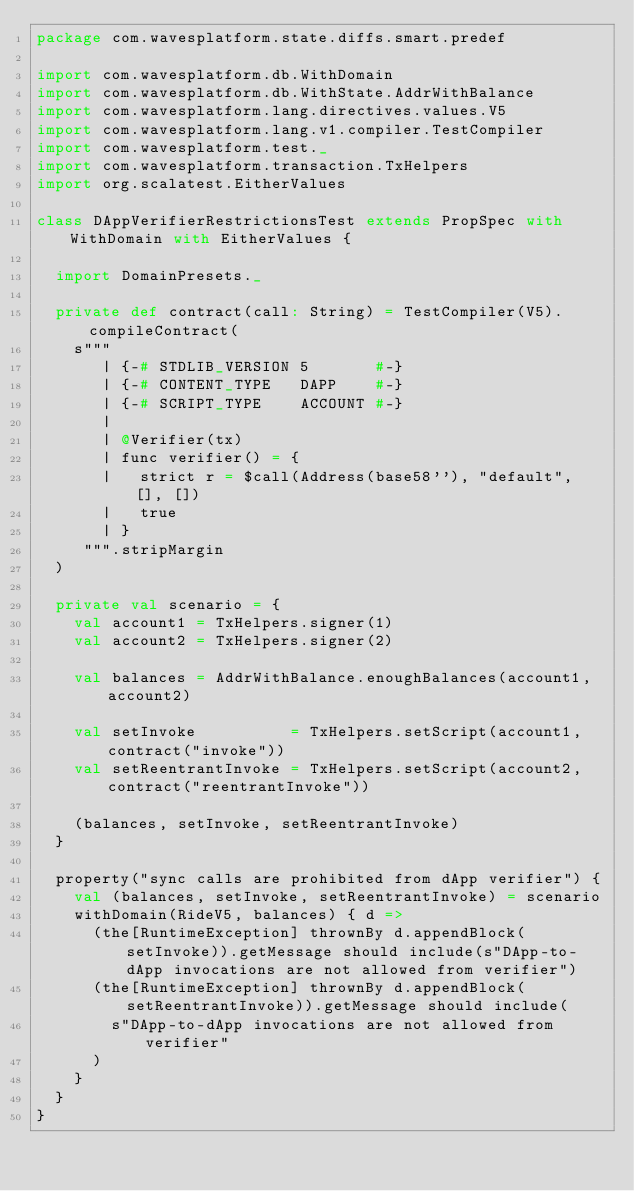Convert code to text. <code><loc_0><loc_0><loc_500><loc_500><_Scala_>package com.wavesplatform.state.diffs.smart.predef

import com.wavesplatform.db.WithDomain
import com.wavesplatform.db.WithState.AddrWithBalance
import com.wavesplatform.lang.directives.values.V5
import com.wavesplatform.lang.v1.compiler.TestCompiler
import com.wavesplatform.test._
import com.wavesplatform.transaction.TxHelpers
import org.scalatest.EitherValues

class DAppVerifierRestrictionsTest extends PropSpec with WithDomain with EitherValues {

  import DomainPresets._

  private def contract(call: String) = TestCompiler(V5).compileContract(
    s"""
       | {-# STDLIB_VERSION 5       #-}
       | {-# CONTENT_TYPE   DAPP    #-}
       | {-# SCRIPT_TYPE    ACCOUNT #-}
       |
       | @Verifier(tx)
       | func verifier() = {
       |   strict r = $call(Address(base58''), "default", [], [])
       |   true
       | }
     """.stripMargin
  )

  private val scenario = {
    val account1 = TxHelpers.signer(1)
    val account2 = TxHelpers.signer(2)

    val balances = AddrWithBalance.enoughBalances(account1, account2)

    val setInvoke          = TxHelpers.setScript(account1, contract("invoke"))
    val setReentrantInvoke = TxHelpers.setScript(account2, contract("reentrantInvoke"))

    (balances, setInvoke, setReentrantInvoke)
  }

  property("sync calls are prohibited from dApp verifier") {
    val (balances, setInvoke, setReentrantInvoke) = scenario
    withDomain(RideV5, balances) { d =>
      (the[RuntimeException] thrownBy d.appendBlock(setInvoke)).getMessage should include(s"DApp-to-dApp invocations are not allowed from verifier")
      (the[RuntimeException] thrownBy d.appendBlock(setReentrantInvoke)).getMessage should include(
        s"DApp-to-dApp invocations are not allowed from verifier"
      )
    }
  }
}
</code> 